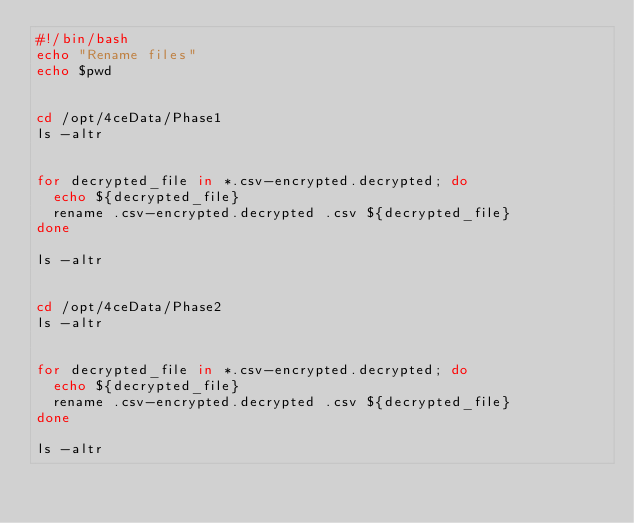<code> <loc_0><loc_0><loc_500><loc_500><_Bash_>#!/bin/bash
echo "Rename files"
echo $pwd


cd /opt/4ceData/Phase1
ls -altr


for decrypted_file in *.csv-encrypted.decrypted; do
  echo ${decrypted_file}
  rename .csv-encrypted.decrypted .csv ${decrypted_file}
done

ls -altr


cd /opt/4ceData/Phase2
ls -altr


for decrypted_file in *.csv-encrypted.decrypted; do
  echo ${decrypted_file}
  rename .csv-encrypted.decrypted .csv ${decrypted_file}
done

ls -altr</code> 